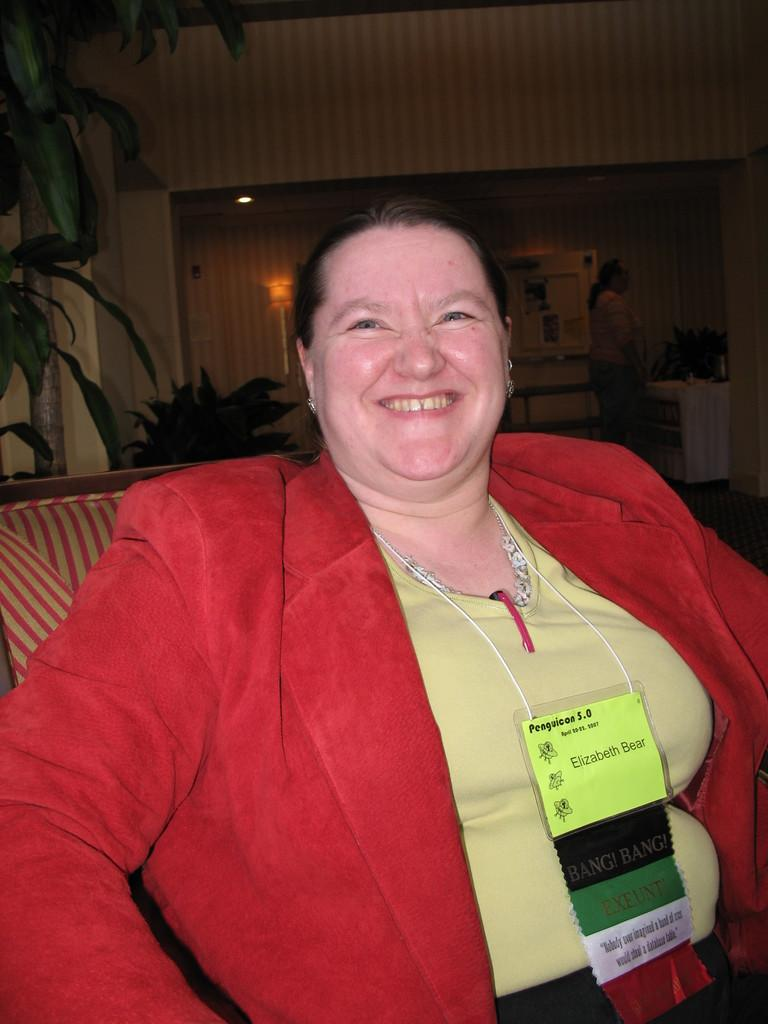What is the expression of the person in the image? The person in the image is smiling. Can you describe the setting of the image? There is another person in the background, plants, a lamp, and a desk in the image. What other objects are present in the image? There are other objects present in the image, but their specific details are not mentioned in the provided facts. How does the baby rub the lamp in the image? There is no baby or lamp present in the image; it only features a person smiling, another person in the background, plants, a lamp, and a desk. 